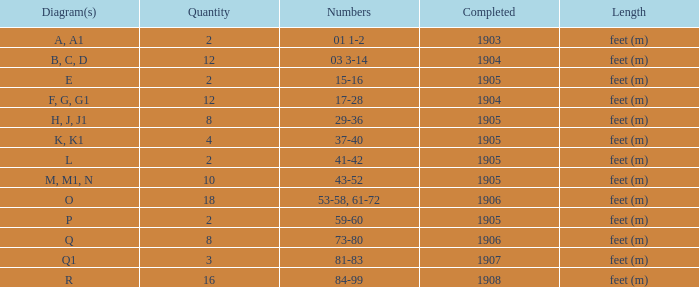For the object having over 10, and figures of 53-58, 61-72, what is the smallest finished? 1906.0. 